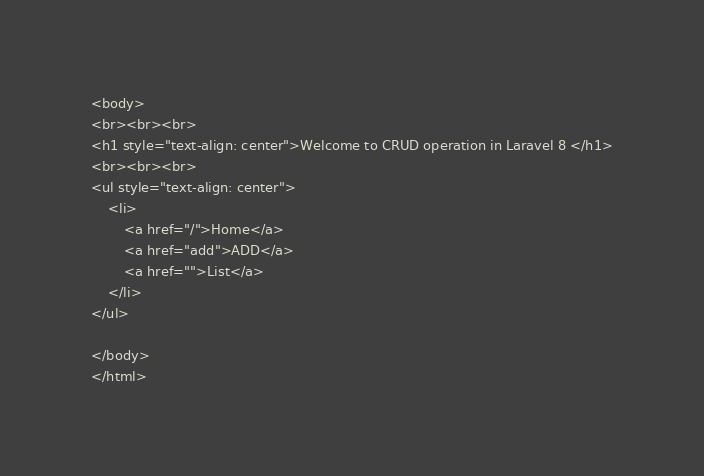<code> <loc_0><loc_0><loc_500><loc_500><_PHP_><body>
<br><br><br>
<h1 style="text-align: center">Welcome to CRUD operation in Laravel 8 </h1>
<br><br><br>
<ul style="text-align: center">
    <li>
        <a href="/">Home</a>
        <a href="add">ADD</a>
        <a href="">List</a>
    </li>
</ul>

</body>
</html>
</code> 